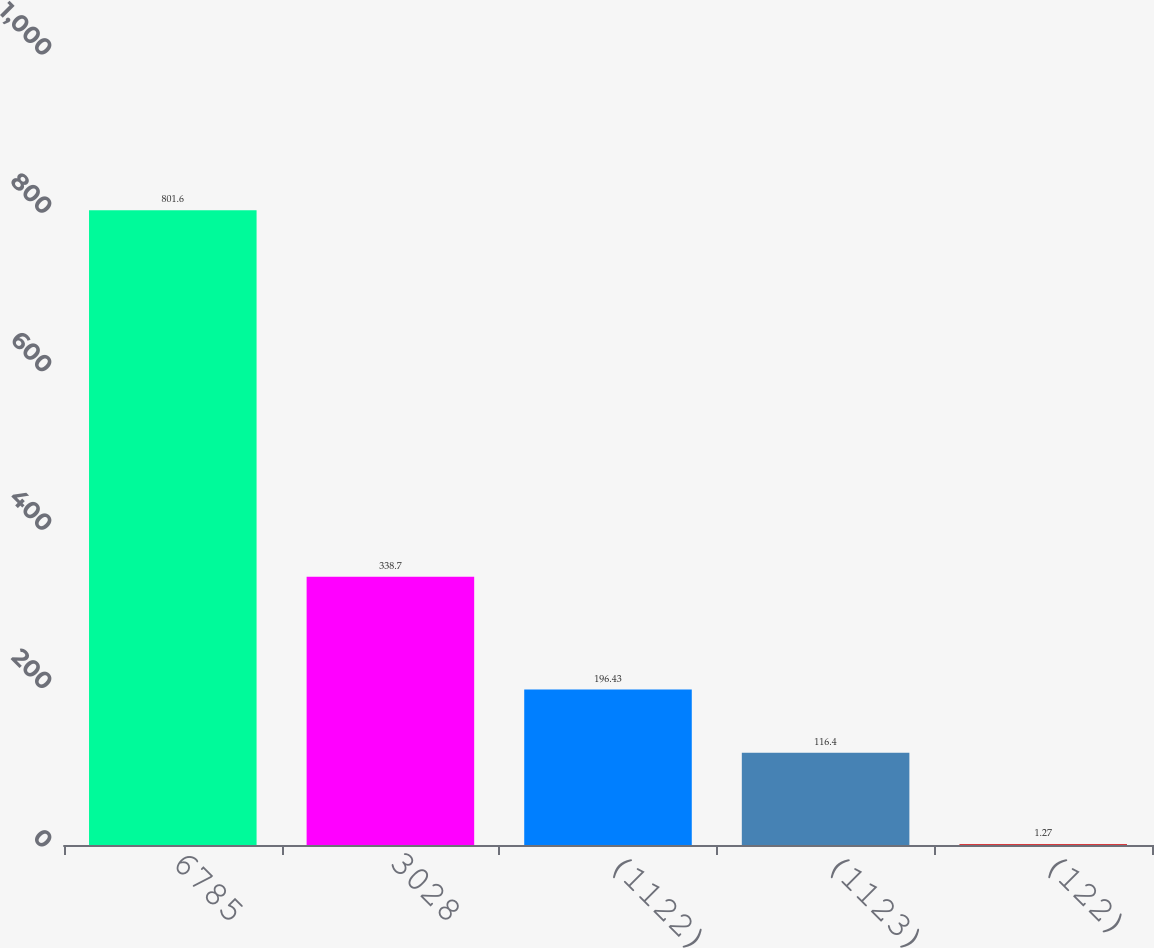<chart> <loc_0><loc_0><loc_500><loc_500><bar_chart><fcel>6785<fcel>3028<fcel>(1122)<fcel>(1123)<fcel>(122)<nl><fcel>801.6<fcel>338.7<fcel>196.43<fcel>116.4<fcel>1.27<nl></chart> 